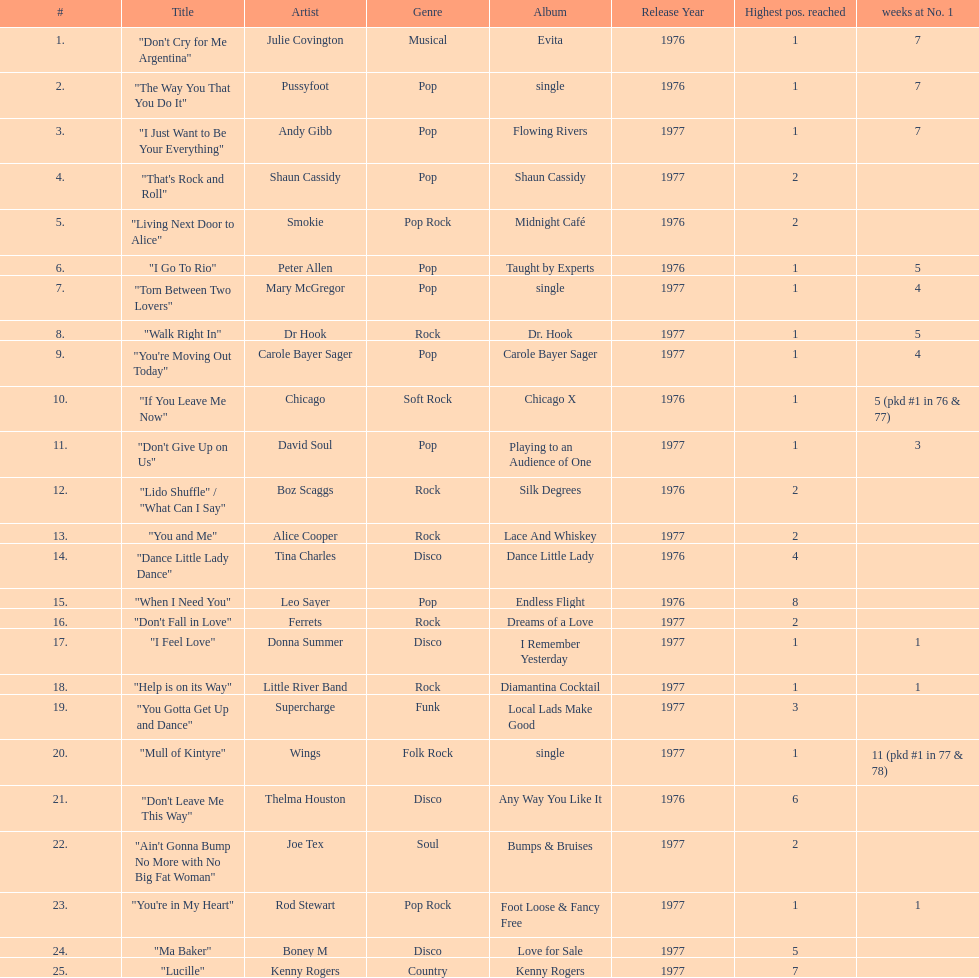Who had the most weeks at number one, according to the table? Wings. 